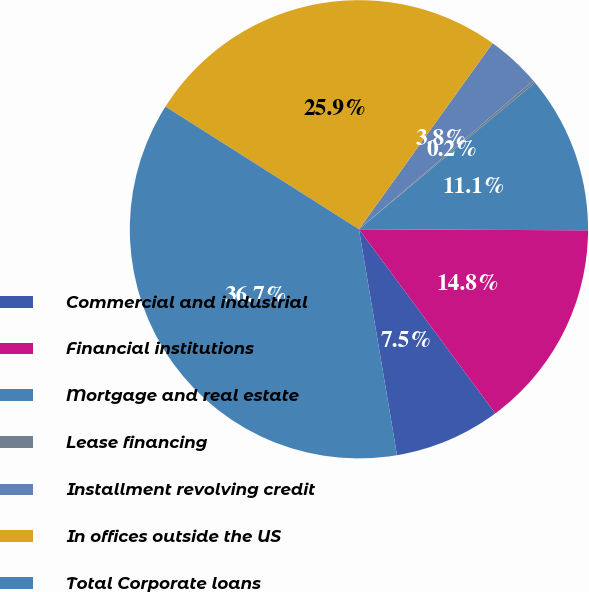Convert chart to OTSL. <chart><loc_0><loc_0><loc_500><loc_500><pie_chart><fcel>Commercial and industrial<fcel>Financial institutions<fcel>Mortgage and real estate<fcel>Lease financing<fcel>Installment revolving credit<fcel>In offices outside the US<fcel>Total Corporate loans<nl><fcel>7.49%<fcel>14.78%<fcel>11.13%<fcel>0.19%<fcel>3.84%<fcel>25.92%<fcel>36.65%<nl></chart> 